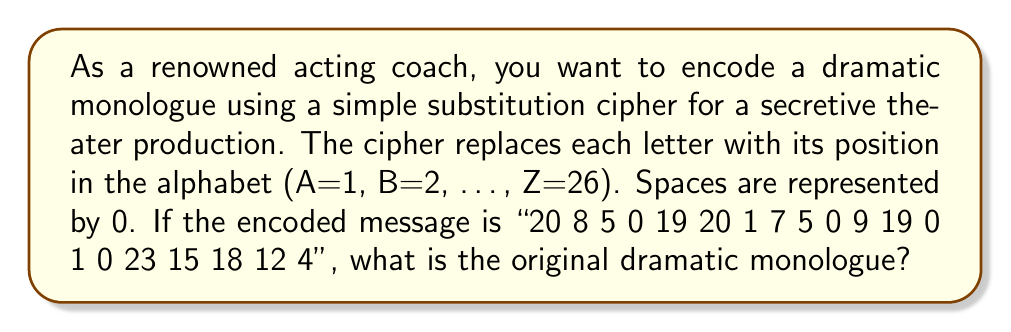What is the answer to this math problem? To decode the message, we need to reverse the substitution cipher:

1. Split the encoded message into individual numbers:
   20 8 5 0 19 20 1 7 5 0 9 19 0 1 0 23 15 18 12 4

2. Replace each number with its corresponding letter:
   - 20 → T (20th letter of the alphabet)
   - 8 → H (8th letter)
   - 5 → E (5th letter)
   - 0 → Space
   - 19 → S (19th letter)
   - 20 → T (20th letter)
   - 1 → A (1st letter)
   - 7 → G (7th letter)
   - 5 → E (5th letter)
   - 0 → Space
   - 9 → I (9th letter)
   - 19 → S (19th letter)
   - 0 → Space
   - 1 → A (1st letter)
   - 0 → Space
   - 23 → W (23rd letter)
   - 15 → O (15th letter)
   - 18 → R (18th letter)
   - 12 → L (12th letter)
   - 4 → D (4th letter)

3. Combine the letters to form the original dramatic monologue:
   "THE STAGE IS A WORLD"

This decoded message is a famous quote often attributed to William Shakespeare, emphasizing the power and significance of theater in representing the world.
Answer: THE STAGE IS A WORLD 